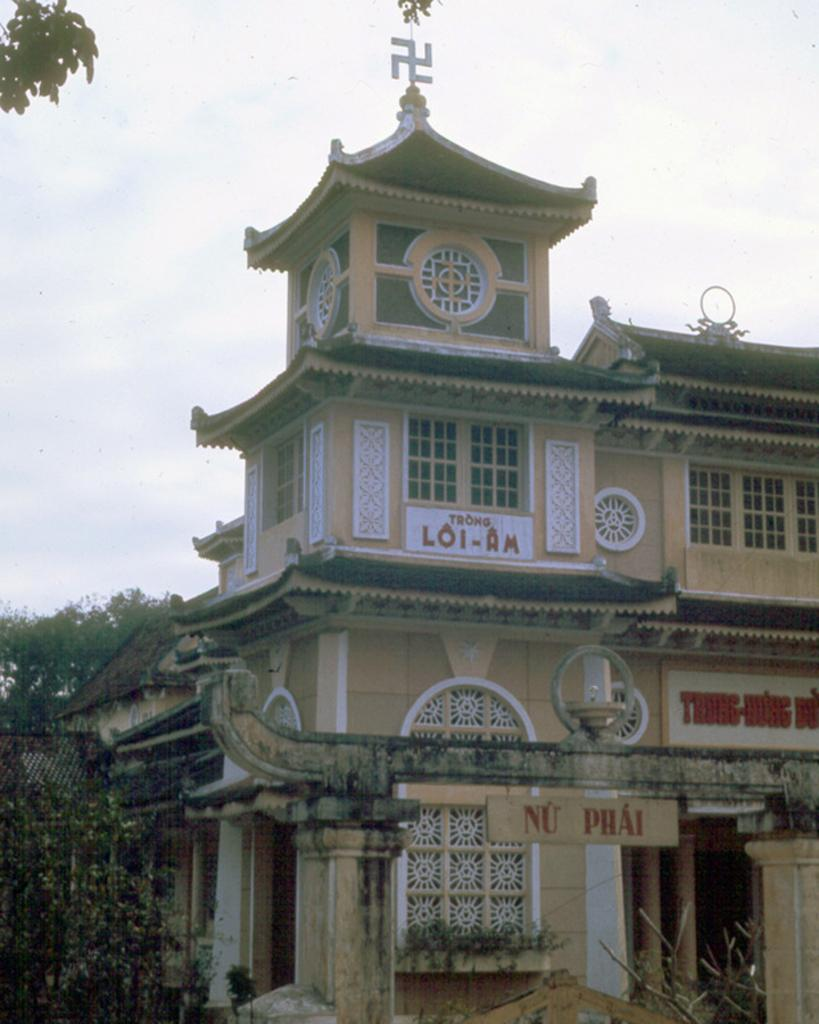What type of natural environment is present at the bottom of the image? There is greenery at the bottom of the image. What structure is located in the middle of the image? There is a building in the middle of the image. What can be seen in the background of the image? There are trees and the sky visible in the background of the image. Can you describe the sky in the image? The sky is visible in the background of the image, and there is a cloud present. Where is the desk located in the image? There is no desk present in the image. What type of rock can be seen in the image? There is no rock present in the image. 